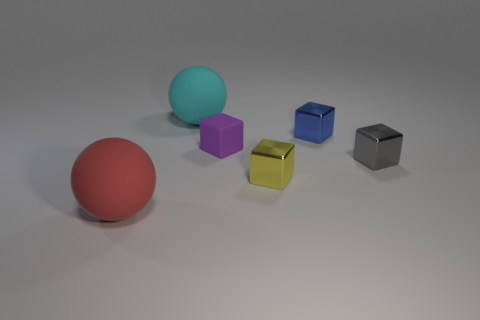There is a matte object that is in front of the tiny gray block; what is its shape?
Offer a very short reply. Sphere. What number of rubber things are there?
Your answer should be very brief. 3. What color is the small cube that is the same material as the big red ball?
Your response must be concise. Purple. How many big things are either purple matte objects or rubber things?
Offer a very short reply. 2. There is a big red object; what number of small gray metal objects are in front of it?
Your answer should be very brief. 0. The other matte thing that is the same shape as the red matte thing is what color?
Provide a succinct answer. Cyan. How many matte objects are yellow cubes or small gray blocks?
Offer a terse response. 0. There is a big rubber ball that is behind the big ball in front of the large cyan rubber thing; is there a tiny yellow thing behind it?
Ensure brevity in your answer.  No. What color is the small matte block?
Give a very brief answer. Purple. Do the big object that is on the right side of the red matte thing and the tiny yellow metal thing have the same shape?
Give a very brief answer. No. 